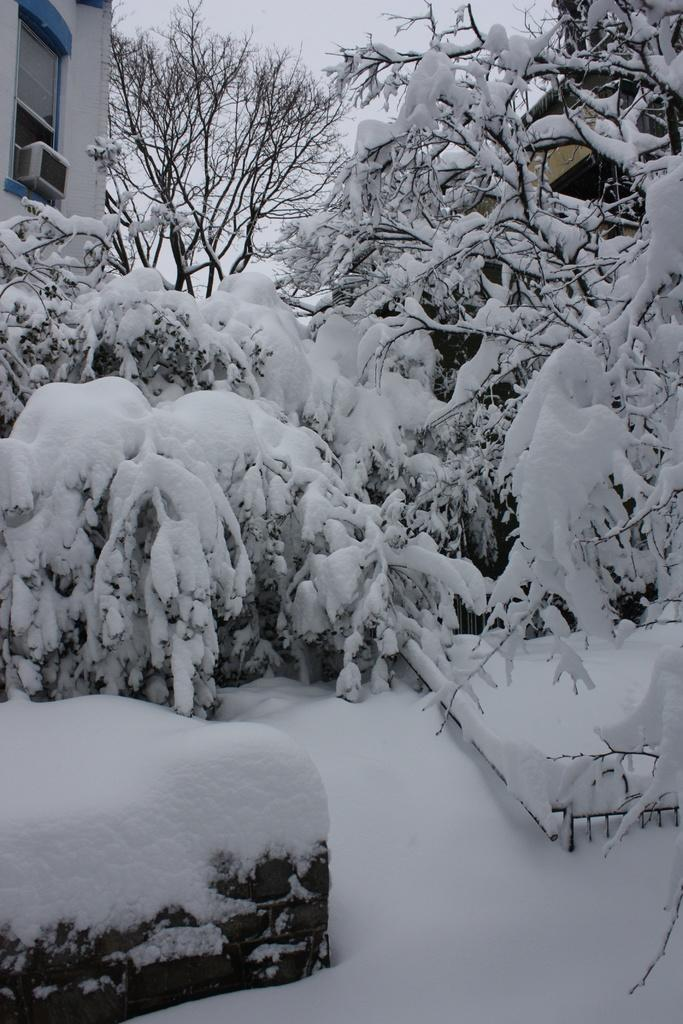What type of vegetation can be seen in the image? There are trees in the image. What is covering the ground in the image? The ground is covered by snow. Are there any structures visible in the image? Yes, there are buildings with snow in the image. What part of the natural environment is visible in the image? The sky is visible in the image. What type of machine is being used for scientific research in the image? There is no machine or scientific research present in the image; it features trees, snow-covered ground, buildings, and a visible sky. Where is the seat located in the image? There is no seat present in the image. 